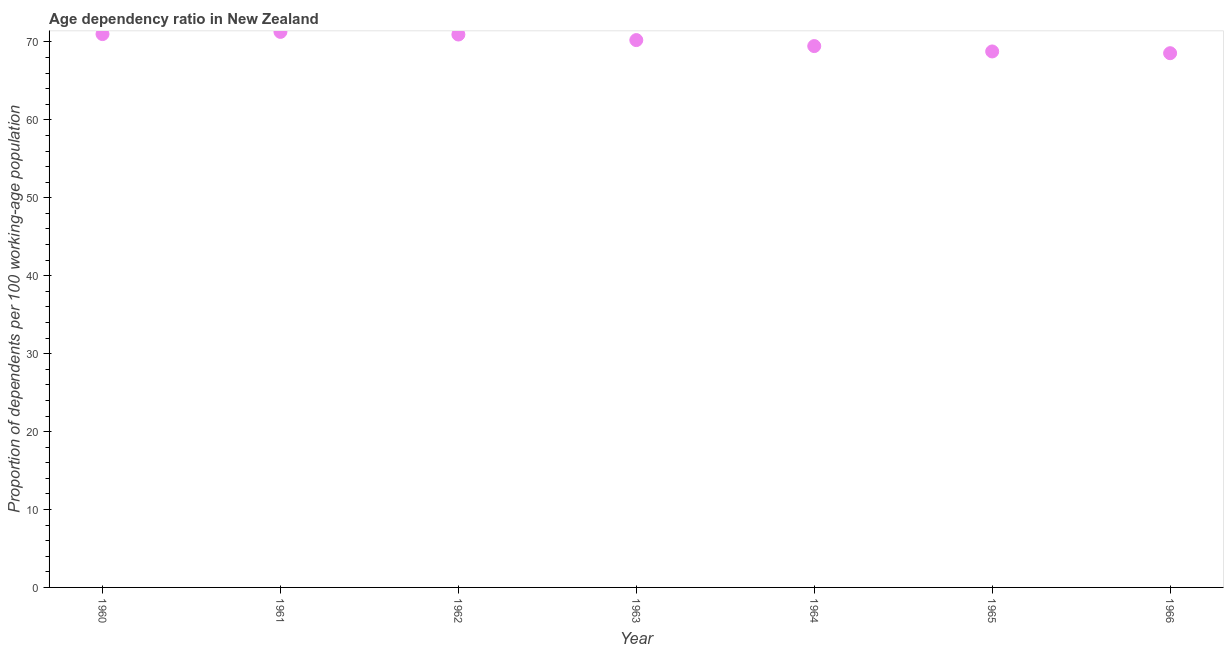What is the age dependency ratio in 1965?
Ensure brevity in your answer.  68.79. Across all years, what is the maximum age dependency ratio?
Make the answer very short. 71.3. Across all years, what is the minimum age dependency ratio?
Offer a terse response. 68.56. In which year was the age dependency ratio maximum?
Offer a very short reply. 1961. In which year was the age dependency ratio minimum?
Offer a very short reply. 1966. What is the sum of the age dependency ratio?
Offer a very short reply. 490.34. What is the difference between the age dependency ratio in 1963 and 1964?
Offer a terse response. 0.77. What is the average age dependency ratio per year?
Provide a short and direct response. 70.05. What is the median age dependency ratio?
Your answer should be very brief. 70.24. Do a majority of the years between 1962 and 1964 (inclusive) have age dependency ratio greater than 66 ?
Offer a terse response. Yes. What is the ratio of the age dependency ratio in 1960 to that in 1963?
Offer a terse response. 1.01. What is the difference between the highest and the second highest age dependency ratio?
Your answer should be compact. 0.28. What is the difference between the highest and the lowest age dependency ratio?
Provide a succinct answer. 2.73. In how many years, is the age dependency ratio greater than the average age dependency ratio taken over all years?
Your answer should be very brief. 4. Does the age dependency ratio monotonically increase over the years?
Offer a very short reply. No. How many dotlines are there?
Offer a terse response. 1. Are the values on the major ticks of Y-axis written in scientific E-notation?
Give a very brief answer. No. Does the graph contain grids?
Give a very brief answer. No. What is the title of the graph?
Give a very brief answer. Age dependency ratio in New Zealand. What is the label or title of the X-axis?
Your response must be concise. Year. What is the label or title of the Y-axis?
Provide a succinct answer. Proportion of dependents per 100 working-age population. What is the Proportion of dependents per 100 working-age population in 1960?
Make the answer very short. 71.02. What is the Proportion of dependents per 100 working-age population in 1961?
Offer a very short reply. 71.3. What is the Proportion of dependents per 100 working-age population in 1962?
Offer a terse response. 70.96. What is the Proportion of dependents per 100 working-age population in 1963?
Your answer should be compact. 70.24. What is the Proportion of dependents per 100 working-age population in 1964?
Offer a terse response. 69.48. What is the Proportion of dependents per 100 working-age population in 1965?
Offer a very short reply. 68.79. What is the Proportion of dependents per 100 working-age population in 1966?
Give a very brief answer. 68.56. What is the difference between the Proportion of dependents per 100 working-age population in 1960 and 1961?
Offer a terse response. -0.28. What is the difference between the Proportion of dependents per 100 working-age population in 1960 and 1962?
Offer a terse response. 0.06. What is the difference between the Proportion of dependents per 100 working-age population in 1960 and 1963?
Your answer should be compact. 0.77. What is the difference between the Proportion of dependents per 100 working-age population in 1960 and 1964?
Provide a succinct answer. 1.54. What is the difference between the Proportion of dependents per 100 working-age population in 1960 and 1965?
Offer a very short reply. 2.23. What is the difference between the Proportion of dependents per 100 working-age population in 1960 and 1966?
Make the answer very short. 2.45. What is the difference between the Proportion of dependents per 100 working-age population in 1961 and 1962?
Provide a short and direct response. 0.34. What is the difference between the Proportion of dependents per 100 working-age population in 1961 and 1963?
Your response must be concise. 1.05. What is the difference between the Proportion of dependents per 100 working-age population in 1961 and 1964?
Keep it short and to the point. 1.82. What is the difference between the Proportion of dependents per 100 working-age population in 1961 and 1965?
Provide a short and direct response. 2.51. What is the difference between the Proportion of dependents per 100 working-age population in 1961 and 1966?
Provide a short and direct response. 2.73. What is the difference between the Proportion of dependents per 100 working-age population in 1962 and 1963?
Provide a succinct answer. 0.72. What is the difference between the Proportion of dependents per 100 working-age population in 1962 and 1964?
Your answer should be compact. 1.48. What is the difference between the Proportion of dependents per 100 working-age population in 1962 and 1965?
Your response must be concise. 2.17. What is the difference between the Proportion of dependents per 100 working-age population in 1962 and 1966?
Make the answer very short. 2.4. What is the difference between the Proportion of dependents per 100 working-age population in 1963 and 1964?
Your answer should be compact. 0.77. What is the difference between the Proportion of dependents per 100 working-age population in 1963 and 1965?
Make the answer very short. 1.46. What is the difference between the Proportion of dependents per 100 working-age population in 1963 and 1966?
Make the answer very short. 1.68. What is the difference between the Proportion of dependents per 100 working-age population in 1964 and 1965?
Provide a short and direct response. 0.69. What is the difference between the Proportion of dependents per 100 working-age population in 1964 and 1966?
Offer a very short reply. 0.91. What is the difference between the Proportion of dependents per 100 working-age population in 1965 and 1966?
Your answer should be compact. 0.22. What is the ratio of the Proportion of dependents per 100 working-age population in 1960 to that in 1961?
Keep it short and to the point. 1. What is the ratio of the Proportion of dependents per 100 working-age population in 1960 to that in 1962?
Offer a very short reply. 1. What is the ratio of the Proportion of dependents per 100 working-age population in 1960 to that in 1965?
Offer a terse response. 1.03. What is the ratio of the Proportion of dependents per 100 working-age population in 1960 to that in 1966?
Your answer should be very brief. 1.04. What is the ratio of the Proportion of dependents per 100 working-age population in 1961 to that in 1964?
Your answer should be very brief. 1.03. What is the ratio of the Proportion of dependents per 100 working-age population in 1961 to that in 1965?
Offer a very short reply. 1.04. What is the ratio of the Proportion of dependents per 100 working-age population in 1961 to that in 1966?
Your response must be concise. 1.04. What is the ratio of the Proportion of dependents per 100 working-age population in 1962 to that in 1963?
Your answer should be compact. 1.01. What is the ratio of the Proportion of dependents per 100 working-age population in 1962 to that in 1964?
Ensure brevity in your answer.  1.02. What is the ratio of the Proportion of dependents per 100 working-age population in 1962 to that in 1965?
Your response must be concise. 1.03. What is the ratio of the Proportion of dependents per 100 working-age population in 1962 to that in 1966?
Ensure brevity in your answer.  1.03. What is the ratio of the Proportion of dependents per 100 working-age population in 1963 to that in 1965?
Keep it short and to the point. 1.02. What is the ratio of the Proportion of dependents per 100 working-age population in 1963 to that in 1966?
Give a very brief answer. 1.02. What is the ratio of the Proportion of dependents per 100 working-age population in 1965 to that in 1966?
Your answer should be compact. 1. 